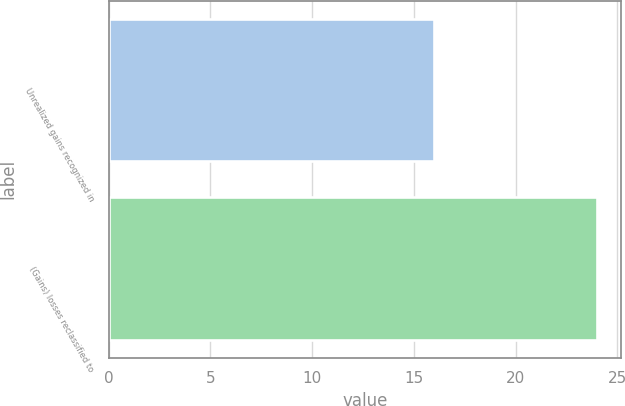<chart> <loc_0><loc_0><loc_500><loc_500><bar_chart><fcel>Unrealized gains recognized in<fcel>(Gains) losses reclassified to<nl><fcel>16<fcel>24<nl></chart> 